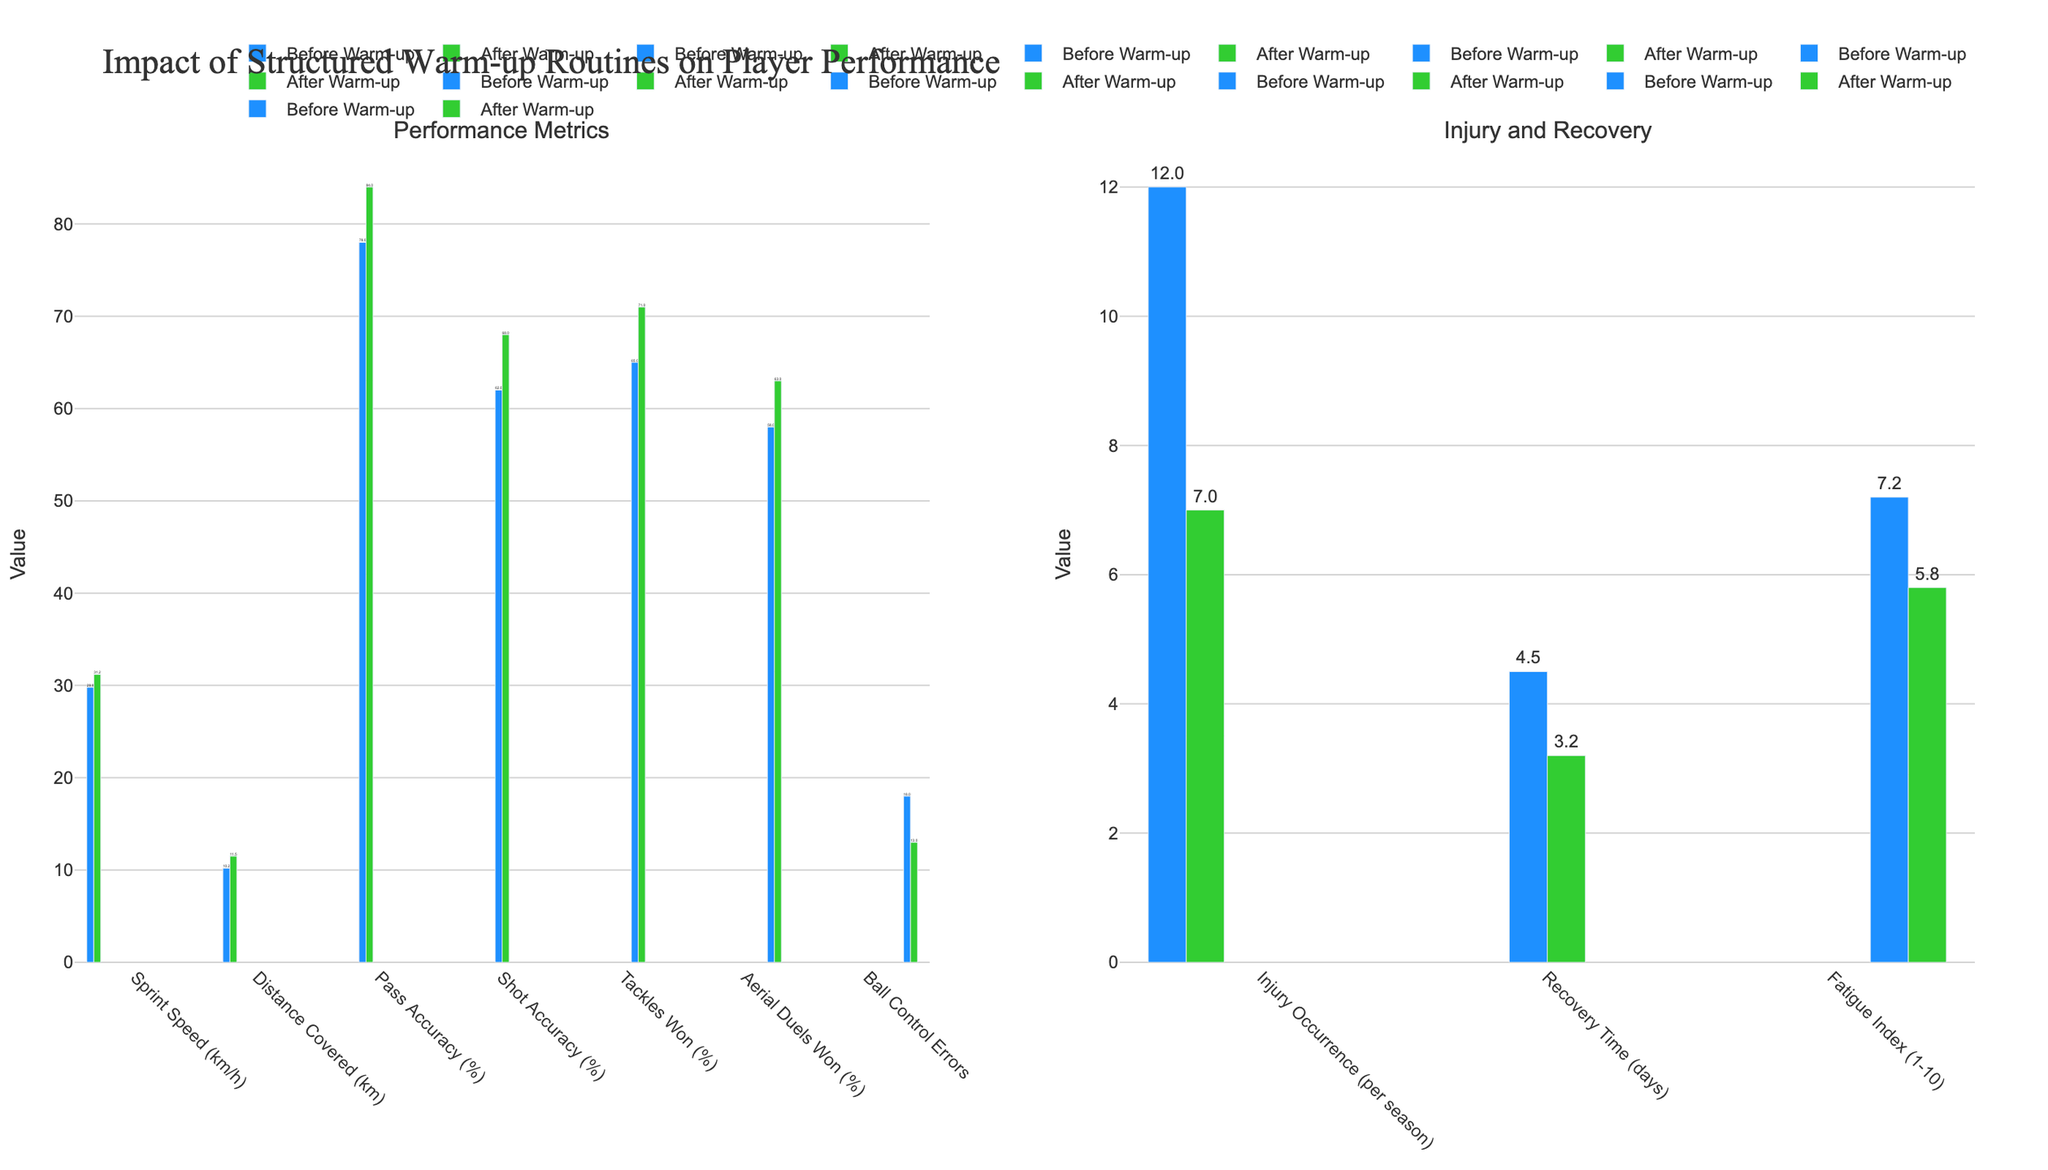What is the improvement in Sprint Speed (km/h) after implementing the structured warm-up routines? Sprint Speed improved from 29.8 km/h to 31.2 km/h. The difference is calculated as 31.2 - 29.8 = 1.4 km/h
Answer: 1.4 km/h How many fewer Ball Control Errors were made after the routines were implemented? Ball Control Errors decreased from 18 to 13. The reduction is calculated as 18 - 13 = 5
Answer: 5 Which metric showed the greatest improvement in percentage points after the warm-up routines? Compare the improvements: Pass Accuracy (84-78=6), Shot Accuracy (68-62=6), Tackles Won (71-65=6), Aerial Duels Won (63-58=5). All are significant, but the highest improvements were Pass Accuracy, Shot Accuracy, and Tackles Won each increasing by 6 percentage points
Answer: Pass Accuracy (%), Shot Accuracy (%), Tackles Won (%) Which value is higher: the reduction in Injury Occurrence per season or the reduction in Fatigue Index? Calculate the reductions: Injury Occurrence decreased from 12 to 7, which is 5 (12 - 7). Fatigue Index decreased from 7.2 to 5.8, which is 1.4 (7.2 - 5.8). The reduction in Injury Occurrence per season is higher than the reduction in Fatigue Index
Answer: Injury Occurrence By how many days did Recovery Time improve after the structured warm-up routines were implemented? Recovery Time improved from 4.5 days to 3.2 days. The difference is calculated by 4.5 - 3.2 = 1.3 days
Answer: 1.3 days What was the impact on Distance Covered (km) after the structured warm-up routines? Distance Covered increased from 10.2 km to 11.5 km. The difference is calculated as 11.5 - 10.2 = 1.3 km
Answer: 1.3 km Compare the percentage improvement in Sprint Speed (km/h) and Fatigue Index. Which one shows a greater percentage change? Calculate the percentage changes. Sprint Speed: [(31.2 - 29.8) / 29.8] * 100 = 4.7%. Fatigue Index: [(7.2 - 5.8) / 7.2] * 100 = 19.4%. The Fatigue Index shows a greater percentage change
Answer: Fatigue Index Identify the metric that showed a decrease in value after the implementation of structured warm-up routines. The metrics showing a decrease are Injury Occurrence (12 to 7), Recovery Time (4.5 to 3.2), and Fatigue Index (7.2 to 5.8). The metric indicating a decline was Ball Control Errors (18 to 13) as well
Answer: Injury Occurrence, Recovery Time, Fatigue Index, and Ball Control Errors What is the average improvement for Pass Accuracy (%) and Shot Accuracy (%) after the structured warm-up routines? Calculate individual improvements: Pass Accuracy (84 - 78 = 6), Shot Accuracy (68 - 62 = 6). Sum these improvements: 6 + 6 = 12. Average them by dividing by the number of metrics: 12 / 2 = 6
Answer: 6 By how much did Tackles Won (%) improve, and how does this compare to the improvement in Aerial Duels Won (%)? Calculate the improvement for both: Tackles Won (%): 71 - 65 = 6. Aerial Duels Won (%): 63 - 58 = 5. The improvement in Tackles Won (%) is 1 percentage point greater than the improvement in Aerial Duels Won (%)
Answer: 1 percentage point more 